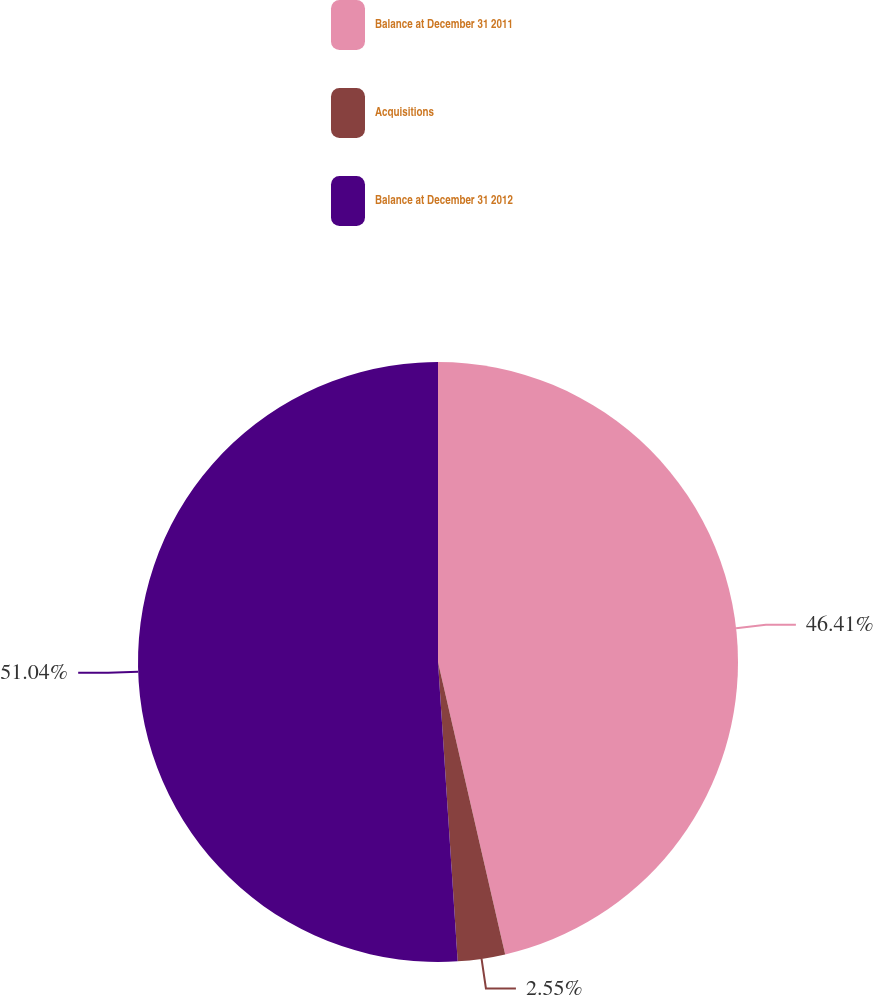Convert chart to OTSL. <chart><loc_0><loc_0><loc_500><loc_500><pie_chart><fcel>Balance at December 31 2011<fcel>Acquisitions<fcel>Balance at December 31 2012<nl><fcel>46.41%<fcel>2.55%<fcel>51.05%<nl></chart> 